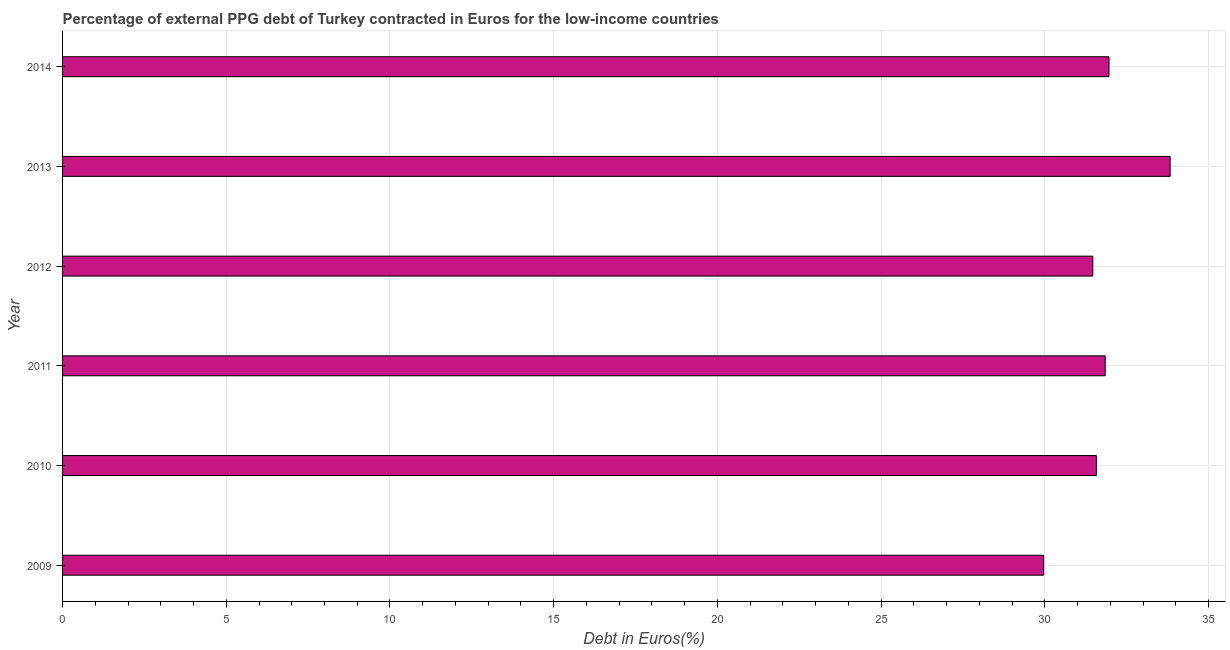Does the graph contain grids?
Your answer should be compact. Yes. What is the title of the graph?
Make the answer very short. Percentage of external PPG debt of Turkey contracted in Euros for the low-income countries. What is the label or title of the X-axis?
Provide a short and direct response. Debt in Euros(%). What is the label or title of the Y-axis?
Make the answer very short. Year. What is the currency composition of ppg debt in 2014?
Your answer should be very brief. 31.96. Across all years, what is the maximum currency composition of ppg debt?
Offer a terse response. 33.83. Across all years, what is the minimum currency composition of ppg debt?
Your answer should be very brief. 29.96. What is the sum of the currency composition of ppg debt?
Your answer should be very brief. 190.63. What is the difference between the currency composition of ppg debt in 2009 and 2012?
Give a very brief answer. -1.5. What is the average currency composition of ppg debt per year?
Ensure brevity in your answer.  31.77. What is the median currency composition of ppg debt?
Provide a succinct answer. 31.71. In how many years, is the currency composition of ppg debt greater than 24 %?
Ensure brevity in your answer.  6. Do a majority of the years between 2009 and 2011 (inclusive) have currency composition of ppg debt greater than 29 %?
Give a very brief answer. Yes. What is the ratio of the currency composition of ppg debt in 2009 to that in 2010?
Offer a very short reply. 0.95. What is the difference between the highest and the second highest currency composition of ppg debt?
Keep it short and to the point. 1.87. What is the difference between the highest and the lowest currency composition of ppg debt?
Provide a succinct answer. 3.86. How many years are there in the graph?
Make the answer very short. 6. What is the difference between two consecutive major ticks on the X-axis?
Offer a very short reply. 5. Are the values on the major ticks of X-axis written in scientific E-notation?
Give a very brief answer. No. What is the Debt in Euros(%) of 2009?
Offer a terse response. 29.96. What is the Debt in Euros(%) of 2010?
Your response must be concise. 31.57. What is the Debt in Euros(%) of 2011?
Your answer should be compact. 31.84. What is the Debt in Euros(%) of 2012?
Your answer should be very brief. 31.46. What is the Debt in Euros(%) in 2013?
Offer a very short reply. 33.83. What is the Debt in Euros(%) in 2014?
Your response must be concise. 31.96. What is the difference between the Debt in Euros(%) in 2009 and 2010?
Make the answer very short. -1.61. What is the difference between the Debt in Euros(%) in 2009 and 2011?
Ensure brevity in your answer.  -1.88. What is the difference between the Debt in Euros(%) in 2009 and 2012?
Give a very brief answer. -1.5. What is the difference between the Debt in Euros(%) in 2009 and 2013?
Provide a short and direct response. -3.86. What is the difference between the Debt in Euros(%) in 2009 and 2014?
Your response must be concise. -2. What is the difference between the Debt in Euros(%) in 2010 and 2011?
Your answer should be very brief. -0.27. What is the difference between the Debt in Euros(%) in 2010 and 2012?
Offer a terse response. 0.11. What is the difference between the Debt in Euros(%) in 2010 and 2013?
Provide a short and direct response. -2.25. What is the difference between the Debt in Euros(%) in 2010 and 2014?
Offer a very short reply. -0.39. What is the difference between the Debt in Euros(%) in 2011 and 2012?
Your answer should be compact. 0.38. What is the difference between the Debt in Euros(%) in 2011 and 2013?
Make the answer very short. -1.98. What is the difference between the Debt in Euros(%) in 2011 and 2014?
Give a very brief answer. -0.12. What is the difference between the Debt in Euros(%) in 2012 and 2013?
Give a very brief answer. -2.36. What is the difference between the Debt in Euros(%) in 2012 and 2014?
Offer a very short reply. -0.5. What is the difference between the Debt in Euros(%) in 2013 and 2014?
Ensure brevity in your answer.  1.87. What is the ratio of the Debt in Euros(%) in 2009 to that in 2010?
Provide a short and direct response. 0.95. What is the ratio of the Debt in Euros(%) in 2009 to that in 2011?
Give a very brief answer. 0.94. What is the ratio of the Debt in Euros(%) in 2009 to that in 2013?
Your answer should be very brief. 0.89. What is the ratio of the Debt in Euros(%) in 2009 to that in 2014?
Provide a short and direct response. 0.94. What is the ratio of the Debt in Euros(%) in 2010 to that in 2011?
Your answer should be very brief. 0.99. What is the ratio of the Debt in Euros(%) in 2010 to that in 2012?
Give a very brief answer. 1. What is the ratio of the Debt in Euros(%) in 2010 to that in 2013?
Offer a terse response. 0.93. What is the ratio of the Debt in Euros(%) in 2011 to that in 2012?
Provide a succinct answer. 1.01. What is the ratio of the Debt in Euros(%) in 2011 to that in 2013?
Provide a short and direct response. 0.94. What is the ratio of the Debt in Euros(%) in 2011 to that in 2014?
Offer a very short reply. 1. What is the ratio of the Debt in Euros(%) in 2012 to that in 2013?
Offer a terse response. 0.93. What is the ratio of the Debt in Euros(%) in 2013 to that in 2014?
Your answer should be very brief. 1.06. 